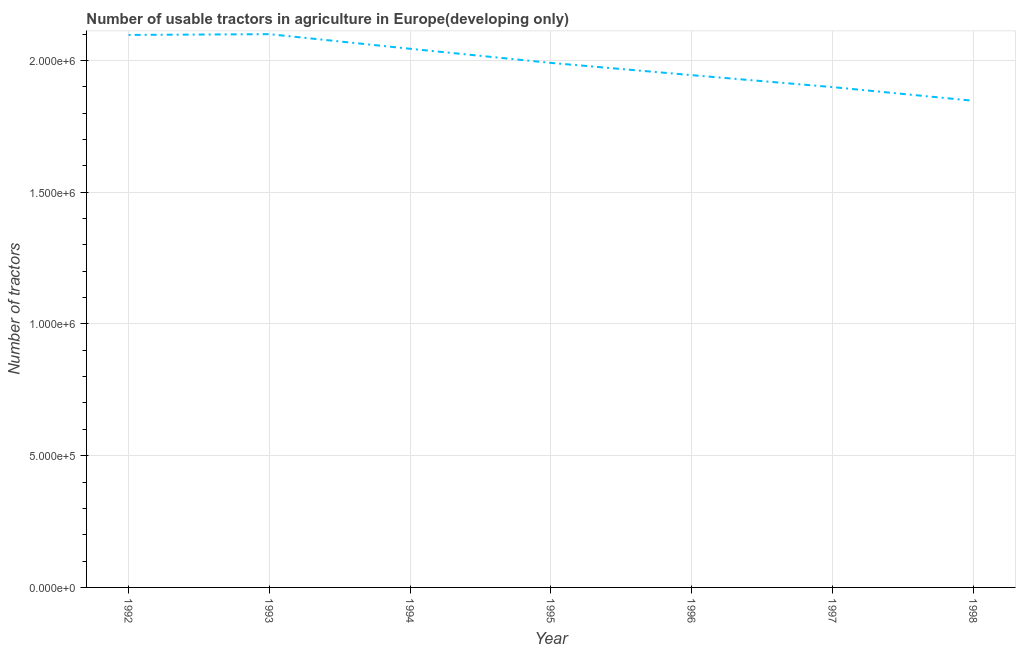What is the number of tractors in 1994?
Your response must be concise. 2.04e+06. Across all years, what is the maximum number of tractors?
Ensure brevity in your answer.  2.10e+06. Across all years, what is the minimum number of tractors?
Keep it short and to the point. 1.85e+06. What is the sum of the number of tractors?
Ensure brevity in your answer.  1.39e+07. What is the difference between the number of tractors in 1994 and 1996?
Ensure brevity in your answer.  1.00e+05. What is the average number of tractors per year?
Ensure brevity in your answer.  1.99e+06. What is the median number of tractors?
Ensure brevity in your answer.  1.99e+06. In how many years, is the number of tractors greater than 1600000 ?
Ensure brevity in your answer.  7. Do a majority of the years between 1996 and 1992 (inclusive) have number of tractors greater than 1700000 ?
Your response must be concise. Yes. What is the ratio of the number of tractors in 1992 to that in 1993?
Provide a short and direct response. 1. Is the number of tractors in 1993 less than that in 1995?
Keep it short and to the point. No. What is the difference between the highest and the second highest number of tractors?
Keep it short and to the point. 2957. Is the sum of the number of tractors in 1997 and 1998 greater than the maximum number of tractors across all years?
Provide a succinct answer. Yes. What is the difference between the highest and the lowest number of tractors?
Your answer should be very brief. 2.53e+05. In how many years, is the number of tractors greater than the average number of tractors taken over all years?
Ensure brevity in your answer.  4. Does the number of tractors monotonically increase over the years?
Keep it short and to the point. No. How many lines are there?
Keep it short and to the point. 1. How many years are there in the graph?
Offer a terse response. 7. What is the title of the graph?
Your answer should be compact. Number of usable tractors in agriculture in Europe(developing only). What is the label or title of the X-axis?
Give a very brief answer. Year. What is the label or title of the Y-axis?
Your answer should be very brief. Number of tractors. What is the Number of tractors of 1992?
Offer a terse response. 2.10e+06. What is the Number of tractors in 1993?
Offer a very short reply. 2.10e+06. What is the Number of tractors of 1994?
Offer a terse response. 2.04e+06. What is the Number of tractors of 1995?
Your answer should be compact. 1.99e+06. What is the Number of tractors in 1996?
Your answer should be compact. 1.94e+06. What is the Number of tractors in 1997?
Your answer should be compact. 1.90e+06. What is the Number of tractors of 1998?
Provide a short and direct response. 1.85e+06. What is the difference between the Number of tractors in 1992 and 1993?
Keep it short and to the point. -2957. What is the difference between the Number of tractors in 1992 and 1994?
Offer a terse response. 5.26e+04. What is the difference between the Number of tractors in 1992 and 1995?
Keep it short and to the point. 1.06e+05. What is the difference between the Number of tractors in 1992 and 1996?
Keep it short and to the point. 1.53e+05. What is the difference between the Number of tractors in 1992 and 1997?
Your response must be concise. 1.98e+05. What is the difference between the Number of tractors in 1992 and 1998?
Keep it short and to the point. 2.50e+05. What is the difference between the Number of tractors in 1993 and 1994?
Your answer should be compact. 5.55e+04. What is the difference between the Number of tractors in 1993 and 1995?
Ensure brevity in your answer.  1.09e+05. What is the difference between the Number of tractors in 1993 and 1996?
Provide a short and direct response. 1.56e+05. What is the difference between the Number of tractors in 1993 and 1997?
Provide a short and direct response. 2.01e+05. What is the difference between the Number of tractors in 1993 and 1998?
Your answer should be very brief. 2.53e+05. What is the difference between the Number of tractors in 1994 and 1995?
Provide a short and direct response. 5.35e+04. What is the difference between the Number of tractors in 1994 and 1996?
Make the answer very short. 1.00e+05. What is the difference between the Number of tractors in 1994 and 1997?
Keep it short and to the point. 1.45e+05. What is the difference between the Number of tractors in 1994 and 1998?
Your response must be concise. 1.97e+05. What is the difference between the Number of tractors in 1995 and 1996?
Provide a short and direct response. 4.65e+04. What is the difference between the Number of tractors in 1995 and 1997?
Keep it short and to the point. 9.19e+04. What is the difference between the Number of tractors in 1995 and 1998?
Keep it short and to the point. 1.44e+05. What is the difference between the Number of tractors in 1996 and 1997?
Keep it short and to the point. 4.54e+04. What is the difference between the Number of tractors in 1996 and 1998?
Your answer should be compact. 9.73e+04. What is the difference between the Number of tractors in 1997 and 1998?
Make the answer very short. 5.19e+04. What is the ratio of the Number of tractors in 1992 to that in 1995?
Provide a short and direct response. 1.05. What is the ratio of the Number of tractors in 1992 to that in 1996?
Your response must be concise. 1.08. What is the ratio of the Number of tractors in 1992 to that in 1997?
Keep it short and to the point. 1.1. What is the ratio of the Number of tractors in 1992 to that in 1998?
Ensure brevity in your answer.  1.14. What is the ratio of the Number of tractors in 1993 to that in 1994?
Your response must be concise. 1.03. What is the ratio of the Number of tractors in 1993 to that in 1995?
Keep it short and to the point. 1.05. What is the ratio of the Number of tractors in 1993 to that in 1996?
Your answer should be very brief. 1.08. What is the ratio of the Number of tractors in 1993 to that in 1997?
Ensure brevity in your answer.  1.11. What is the ratio of the Number of tractors in 1993 to that in 1998?
Offer a terse response. 1.14. What is the ratio of the Number of tractors in 1994 to that in 1996?
Keep it short and to the point. 1.05. What is the ratio of the Number of tractors in 1994 to that in 1997?
Make the answer very short. 1.08. What is the ratio of the Number of tractors in 1994 to that in 1998?
Offer a terse response. 1.11. What is the ratio of the Number of tractors in 1995 to that in 1996?
Your response must be concise. 1.02. What is the ratio of the Number of tractors in 1995 to that in 1997?
Your response must be concise. 1.05. What is the ratio of the Number of tractors in 1995 to that in 1998?
Provide a short and direct response. 1.08. What is the ratio of the Number of tractors in 1996 to that in 1997?
Give a very brief answer. 1.02. What is the ratio of the Number of tractors in 1996 to that in 1998?
Ensure brevity in your answer.  1.05. What is the ratio of the Number of tractors in 1997 to that in 1998?
Your response must be concise. 1.03. 